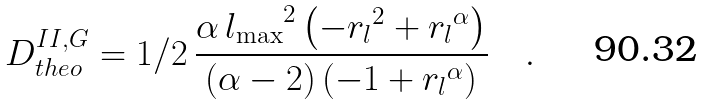<formula> <loc_0><loc_0><loc_500><loc_500>D _ { t h e o } ^ { I I , G } = 1 / 2 \, { \frac { \alpha \, { l _ { \max } } ^ { 2 } \left ( - { r _ { l } } ^ { 2 } + { r _ { l } } ^ { \alpha } \right ) } { \left ( \alpha - 2 \right ) \left ( - 1 + { r _ { l } } ^ { \alpha } \right ) } } \quad .</formula> 